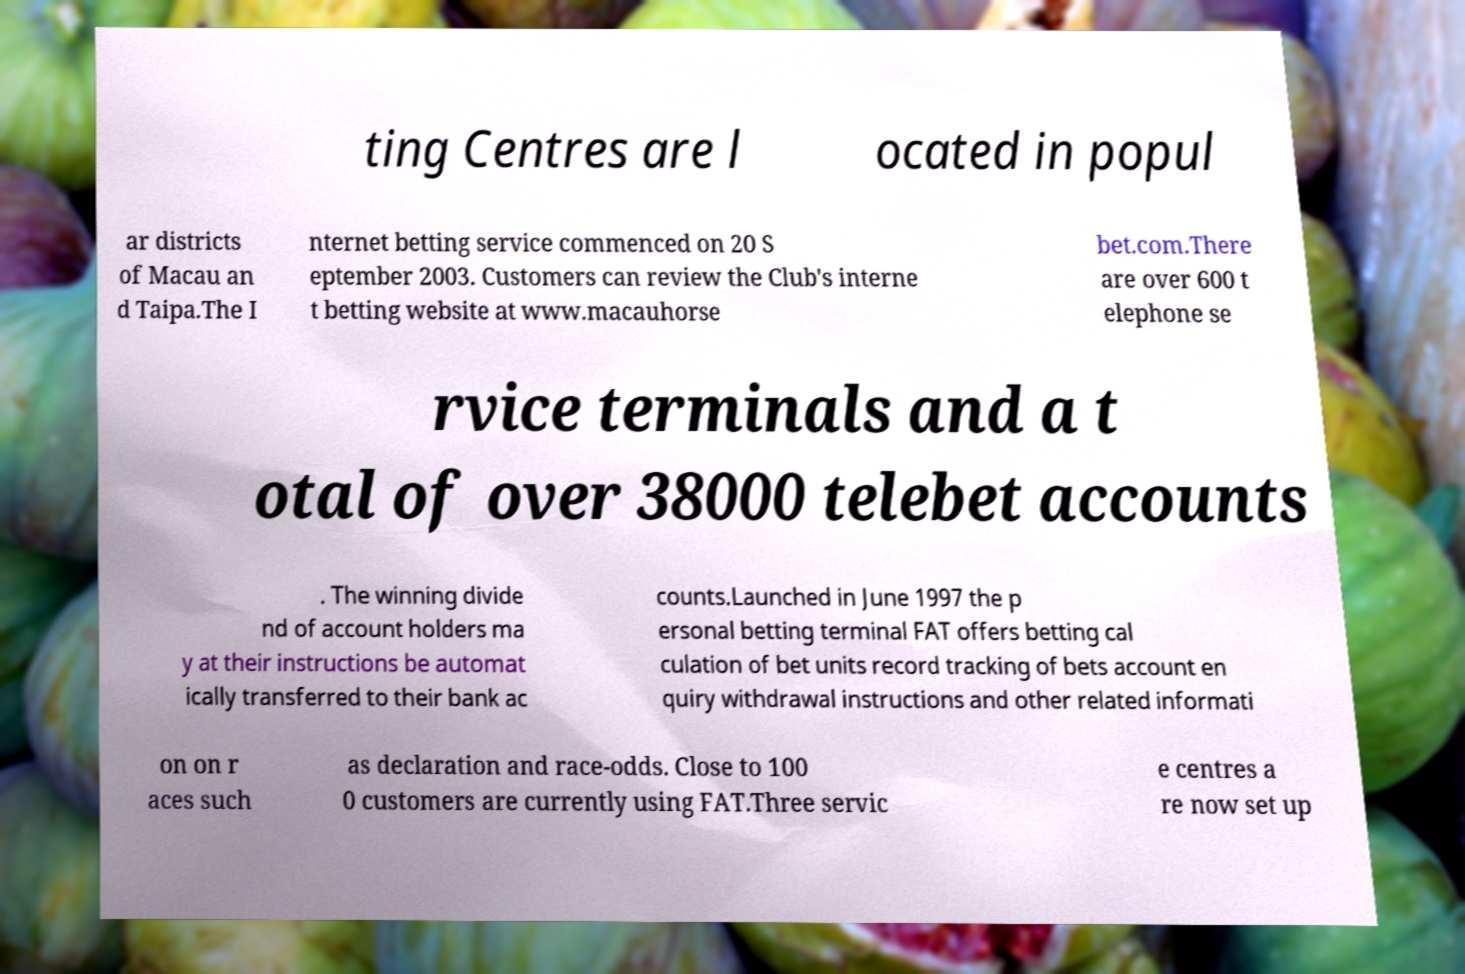Could you extract and type out the text from this image? ting Centres are l ocated in popul ar districts of Macau an d Taipa.The I nternet betting service commenced on 20 S eptember 2003. Customers can review the Club's interne t betting website at www.macauhorse bet.com.There are over 600 t elephone se rvice terminals and a t otal of over 38000 telebet accounts . The winning divide nd of account holders ma y at their instructions be automat ically transferred to their bank ac counts.Launched in June 1997 the p ersonal betting terminal FAT offers betting cal culation of bet units record tracking of bets account en quiry withdrawal instructions and other related informati on on r aces such as declaration and race-odds. Close to 100 0 customers are currently using FAT.Three servic e centres a re now set up 